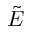Convert formula to latex. <formula><loc_0><loc_0><loc_500><loc_500>\tilde { E }</formula> 